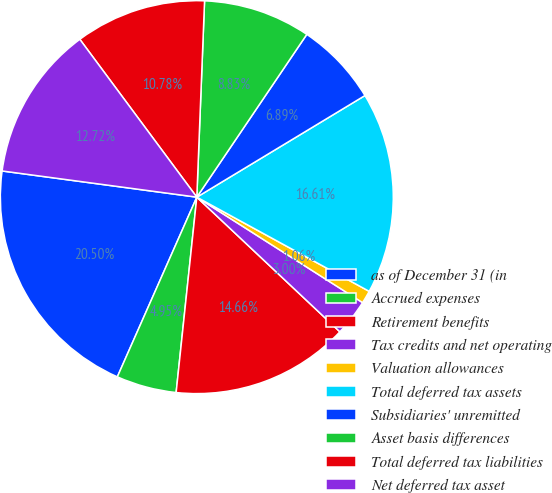Convert chart to OTSL. <chart><loc_0><loc_0><loc_500><loc_500><pie_chart><fcel>as of December 31 (in<fcel>Accrued expenses<fcel>Retirement benefits<fcel>Tax credits and net operating<fcel>Valuation allowances<fcel>Total deferred tax assets<fcel>Subsidiaries' unremitted<fcel>Asset basis differences<fcel>Total deferred tax liabilities<fcel>Net deferred tax asset<nl><fcel>20.5%<fcel>4.95%<fcel>14.66%<fcel>3.0%<fcel>1.06%<fcel>16.61%<fcel>6.89%<fcel>8.83%<fcel>10.78%<fcel>12.72%<nl></chart> 